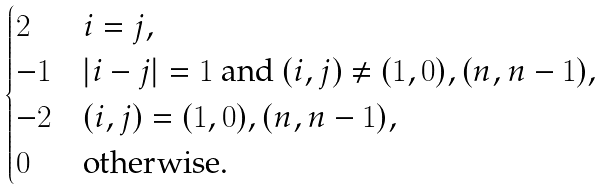<formula> <loc_0><loc_0><loc_500><loc_500>\begin{cases} 2 & i = j , \\ - 1 & | i - j | = 1 \text { and } ( i , j ) \ne ( 1 , 0 ) , ( n , n - 1 ) , \\ - 2 & ( i , j ) = ( 1 , 0 ) , ( n , n - 1 ) , \\ 0 & \text {otherwise.} \end{cases}</formula> 